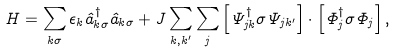<formula> <loc_0><loc_0><loc_500><loc_500>H = \sum _ { { k } \sigma } \epsilon _ { k } \hat { a } ^ { \dag } _ { { k } \sigma } \hat { a } _ { { k } \sigma } + J \sum _ { { k } , { k ^ { \prime } } } \sum _ { j } \left [ \Psi ^ { \dagger } _ { j k } { \sigma } \Psi _ { j { k ^ { \prime } } } \right ] \cdot \left [ \Phi _ { j } ^ { \dagger } { \sigma } \Phi _ { j } \right ] ,</formula> 